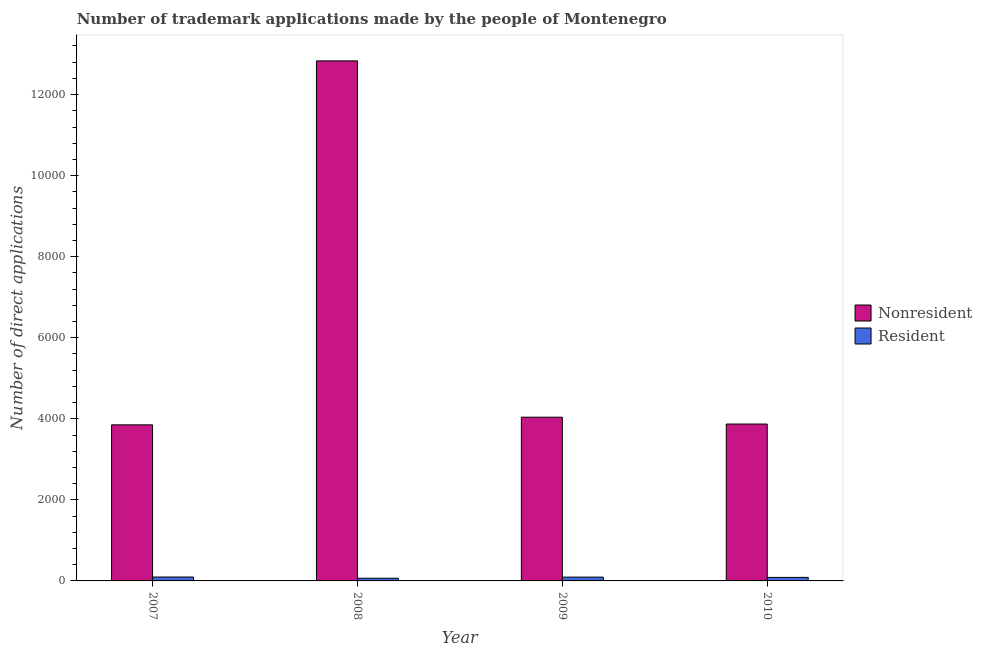How many different coloured bars are there?
Your answer should be very brief. 2. Are the number of bars per tick equal to the number of legend labels?
Provide a short and direct response. Yes. Are the number of bars on each tick of the X-axis equal?
Ensure brevity in your answer.  Yes. How many bars are there on the 4th tick from the left?
Keep it short and to the point. 2. What is the label of the 2nd group of bars from the left?
Your answer should be very brief. 2008. What is the number of trademark applications made by non residents in 2009?
Ensure brevity in your answer.  4040. Across all years, what is the maximum number of trademark applications made by non residents?
Provide a short and direct response. 1.28e+04. Across all years, what is the minimum number of trademark applications made by non residents?
Provide a short and direct response. 3851. In which year was the number of trademark applications made by residents maximum?
Your answer should be compact. 2007. What is the total number of trademark applications made by non residents in the graph?
Offer a very short reply. 2.46e+04. What is the difference between the number of trademark applications made by non residents in 2009 and that in 2010?
Provide a short and direct response. 169. What is the difference between the number of trademark applications made by residents in 2010 and the number of trademark applications made by non residents in 2009?
Ensure brevity in your answer.  -7. What is the average number of trademark applications made by residents per year?
Provide a succinct answer. 85.75. In how many years, is the number of trademark applications made by residents greater than 2400?
Your answer should be compact. 0. What is the ratio of the number of trademark applications made by residents in 2009 to that in 2010?
Your response must be concise. 1.08. Is the number of trademark applications made by non residents in 2007 less than that in 2010?
Ensure brevity in your answer.  Yes. Is the difference between the number of trademark applications made by non residents in 2007 and 2010 greater than the difference between the number of trademark applications made by residents in 2007 and 2010?
Offer a terse response. No. What is the difference between the highest and the second highest number of trademark applications made by residents?
Make the answer very short. 2. What is the difference between the highest and the lowest number of trademark applications made by residents?
Give a very brief answer. 30. In how many years, is the number of trademark applications made by non residents greater than the average number of trademark applications made by non residents taken over all years?
Your answer should be compact. 1. Is the sum of the number of trademark applications made by non residents in 2009 and 2010 greater than the maximum number of trademark applications made by residents across all years?
Offer a terse response. No. What does the 1st bar from the left in 2010 represents?
Your answer should be compact. Nonresident. What does the 1st bar from the right in 2007 represents?
Provide a short and direct response. Resident. Are all the bars in the graph horizontal?
Provide a succinct answer. No. How many years are there in the graph?
Your answer should be very brief. 4. Does the graph contain grids?
Provide a succinct answer. No. Where does the legend appear in the graph?
Give a very brief answer. Center right. What is the title of the graph?
Offer a terse response. Number of trademark applications made by the people of Montenegro. Does "Birth rate" appear as one of the legend labels in the graph?
Your answer should be very brief. No. What is the label or title of the Y-axis?
Give a very brief answer. Number of direct applications. What is the Number of direct applications in Nonresident in 2007?
Make the answer very short. 3851. What is the Number of direct applications in Resident in 2007?
Provide a short and direct response. 96. What is the Number of direct applications in Nonresident in 2008?
Your response must be concise. 1.28e+04. What is the Number of direct applications of Nonresident in 2009?
Offer a terse response. 4040. What is the Number of direct applications in Resident in 2009?
Your answer should be compact. 94. What is the Number of direct applications in Nonresident in 2010?
Your response must be concise. 3871. Across all years, what is the maximum Number of direct applications in Nonresident?
Make the answer very short. 1.28e+04. Across all years, what is the maximum Number of direct applications of Resident?
Offer a terse response. 96. Across all years, what is the minimum Number of direct applications in Nonresident?
Your answer should be compact. 3851. What is the total Number of direct applications of Nonresident in the graph?
Your answer should be compact. 2.46e+04. What is the total Number of direct applications of Resident in the graph?
Your response must be concise. 343. What is the difference between the Number of direct applications of Nonresident in 2007 and that in 2008?
Ensure brevity in your answer.  -8981. What is the difference between the Number of direct applications in Resident in 2007 and that in 2008?
Make the answer very short. 30. What is the difference between the Number of direct applications of Nonresident in 2007 and that in 2009?
Provide a succinct answer. -189. What is the difference between the Number of direct applications of Nonresident in 2007 and that in 2010?
Provide a short and direct response. -20. What is the difference between the Number of direct applications in Resident in 2007 and that in 2010?
Provide a short and direct response. 9. What is the difference between the Number of direct applications of Nonresident in 2008 and that in 2009?
Give a very brief answer. 8792. What is the difference between the Number of direct applications in Nonresident in 2008 and that in 2010?
Your answer should be very brief. 8961. What is the difference between the Number of direct applications in Resident in 2008 and that in 2010?
Provide a short and direct response. -21. What is the difference between the Number of direct applications in Nonresident in 2009 and that in 2010?
Your answer should be compact. 169. What is the difference between the Number of direct applications in Nonresident in 2007 and the Number of direct applications in Resident in 2008?
Your answer should be compact. 3785. What is the difference between the Number of direct applications in Nonresident in 2007 and the Number of direct applications in Resident in 2009?
Make the answer very short. 3757. What is the difference between the Number of direct applications of Nonresident in 2007 and the Number of direct applications of Resident in 2010?
Provide a short and direct response. 3764. What is the difference between the Number of direct applications of Nonresident in 2008 and the Number of direct applications of Resident in 2009?
Ensure brevity in your answer.  1.27e+04. What is the difference between the Number of direct applications in Nonresident in 2008 and the Number of direct applications in Resident in 2010?
Offer a very short reply. 1.27e+04. What is the difference between the Number of direct applications in Nonresident in 2009 and the Number of direct applications in Resident in 2010?
Your response must be concise. 3953. What is the average Number of direct applications in Nonresident per year?
Your answer should be compact. 6148.5. What is the average Number of direct applications of Resident per year?
Ensure brevity in your answer.  85.75. In the year 2007, what is the difference between the Number of direct applications of Nonresident and Number of direct applications of Resident?
Keep it short and to the point. 3755. In the year 2008, what is the difference between the Number of direct applications of Nonresident and Number of direct applications of Resident?
Ensure brevity in your answer.  1.28e+04. In the year 2009, what is the difference between the Number of direct applications of Nonresident and Number of direct applications of Resident?
Provide a succinct answer. 3946. In the year 2010, what is the difference between the Number of direct applications in Nonresident and Number of direct applications in Resident?
Make the answer very short. 3784. What is the ratio of the Number of direct applications in Nonresident in 2007 to that in 2008?
Make the answer very short. 0.3. What is the ratio of the Number of direct applications in Resident in 2007 to that in 2008?
Your answer should be compact. 1.45. What is the ratio of the Number of direct applications in Nonresident in 2007 to that in 2009?
Offer a terse response. 0.95. What is the ratio of the Number of direct applications of Resident in 2007 to that in 2009?
Make the answer very short. 1.02. What is the ratio of the Number of direct applications of Nonresident in 2007 to that in 2010?
Keep it short and to the point. 0.99. What is the ratio of the Number of direct applications in Resident in 2007 to that in 2010?
Provide a short and direct response. 1.1. What is the ratio of the Number of direct applications of Nonresident in 2008 to that in 2009?
Ensure brevity in your answer.  3.18. What is the ratio of the Number of direct applications in Resident in 2008 to that in 2009?
Offer a terse response. 0.7. What is the ratio of the Number of direct applications in Nonresident in 2008 to that in 2010?
Keep it short and to the point. 3.31. What is the ratio of the Number of direct applications in Resident in 2008 to that in 2010?
Provide a short and direct response. 0.76. What is the ratio of the Number of direct applications of Nonresident in 2009 to that in 2010?
Your answer should be very brief. 1.04. What is the ratio of the Number of direct applications in Resident in 2009 to that in 2010?
Offer a terse response. 1.08. What is the difference between the highest and the second highest Number of direct applications in Nonresident?
Make the answer very short. 8792. What is the difference between the highest and the lowest Number of direct applications in Nonresident?
Keep it short and to the point. 8981. 